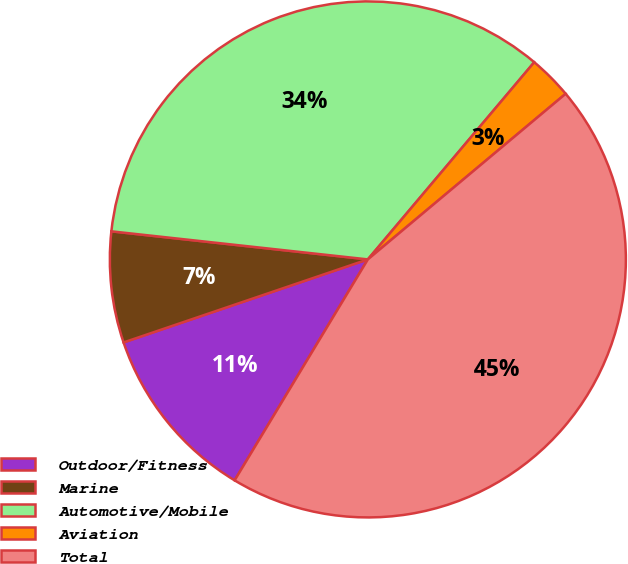<chart> <loc_0><loc_0><loc_500><loc_500><pie_chart><fcel>Outdoor/Fitness<fcel>Marine<fcel>Automotive/Mobile<fcel>Aviation<fcel>Total<nl><fcel>11.15%<fcel>6.95%<fcel>34.42%<fcel>2.75%<fcel>44.73%<nl></chart> 